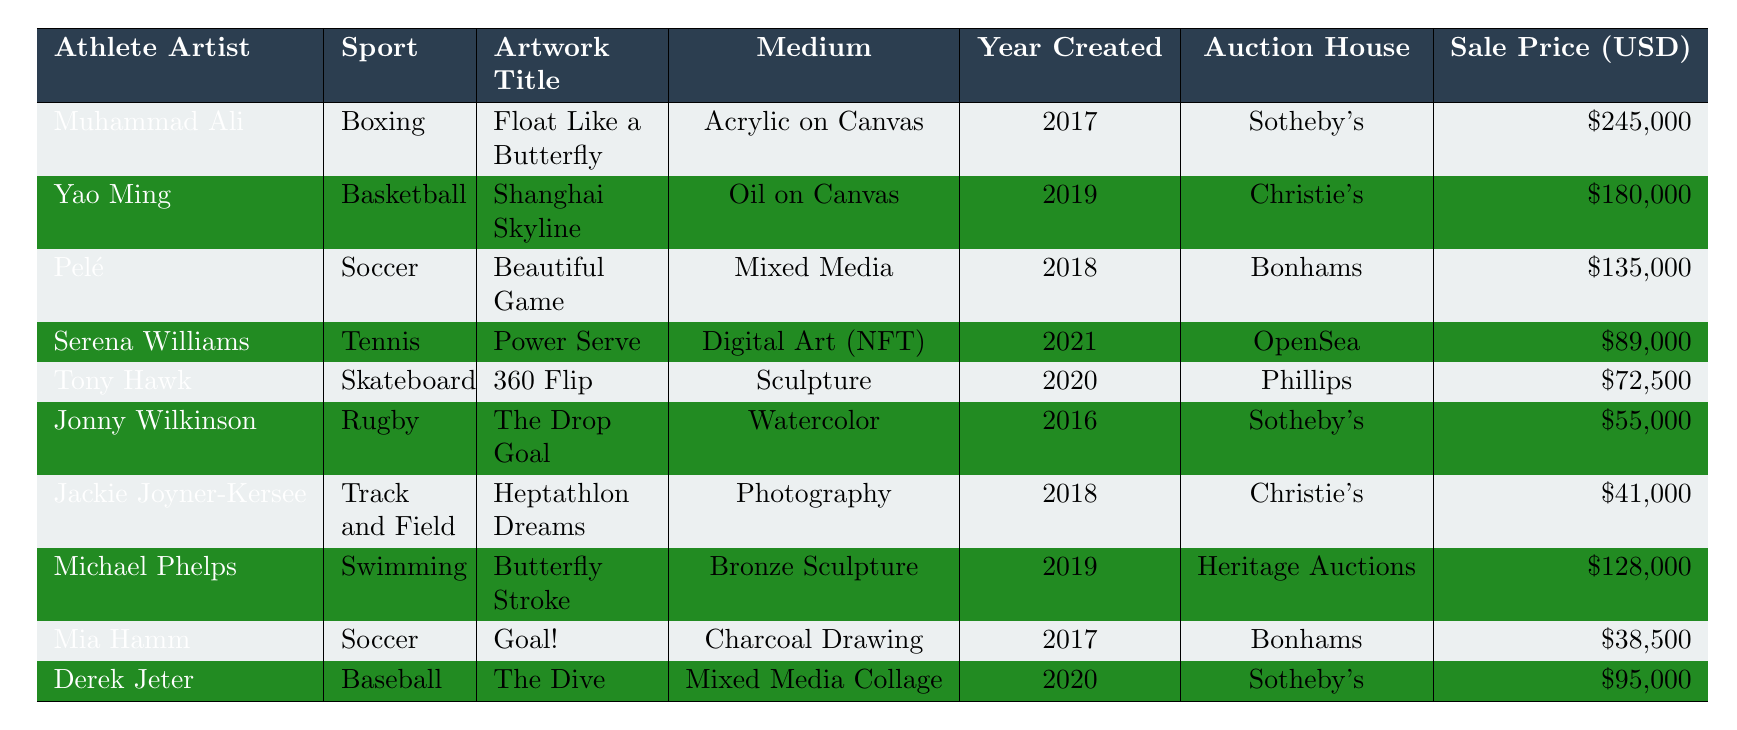What is the highest auction price for an artwork created by a retired professional athlete? The highest auction price listed in the table is \$245,000 for Muhammad Ali's artwork "Float Like a Butterfly."
Answer: \$245,000 Which athlete created the artwork titled "Butterfly Stroke"? The table indicates that the artwork "Butterfly Stroke" was created by Michael Phelps.
Answer: Michael Phelps How many artworks were sold for more than \$100,000? The artworks sold for more than \$100,000 are "Float Like a Butterfly" (Muhammad Ali), "Shanghai Skyline" (Yao Ming), "Beautiful Game" (Pelé), and "Butterfly Stroke" (Michael Phelps). This totals to four artworks.
Answer: 4 Which medium was used for the artwork "Power Serve"? According to the table, "Power Serve" is a digital art piece using NFT (Non-Fungible Token) as its medium.
Answer: Digital Art (NFT) What is the average auction price of the artworks listed in the table? The total auction prices are \$245,000 + \$180,000 + \$135,000 + \$89,000 + \$72,500 + \$55,000 + \$41,000 + \$128,000 + \$38,500 + \$95,000 = \$1,000,000. There are 10 artworks, so the average price is \$1,000,000 / 10 = \$100,000.
Answer: \$100,000 Which sport has the artwork "360 Flip," and what is its auction price? "360 Flip" was created by Tony Hawk, who is associated with skateboarding, and it sold for \$72,500.
Answer: Skateboarding, \$72,500 Is there an artwork from the table created in 2021? Yes, the table shows that "Power Serve" by Serena Williams was created in 2021.
Answer: Yes Which two athletes have artworks sold at Sotheby's? The athletes with artworks sold at Sotheby’s are Muhammad Ali and Jonny Wilkinson.
Answer: Muhammad Ali and Jonny Wilkinson What are the years in which artworks were created that sold for less than \$50,000? The artworks that sold for less than \$50,000 are "Heptathlon Dreams" (Jackie Joyner-Kersee) in 2018 and "Goal!" (Mia Hamm) in 2017. Both of these artworks fall under the specified price range.
Answer: 2017, 2018 Which auction house sold the artwork titled "The Drop Goal"? The table states that "The Drop Goal," created by Jonny Wilkinson, was sold at Sotheby's.
Answer: Sotheby's 